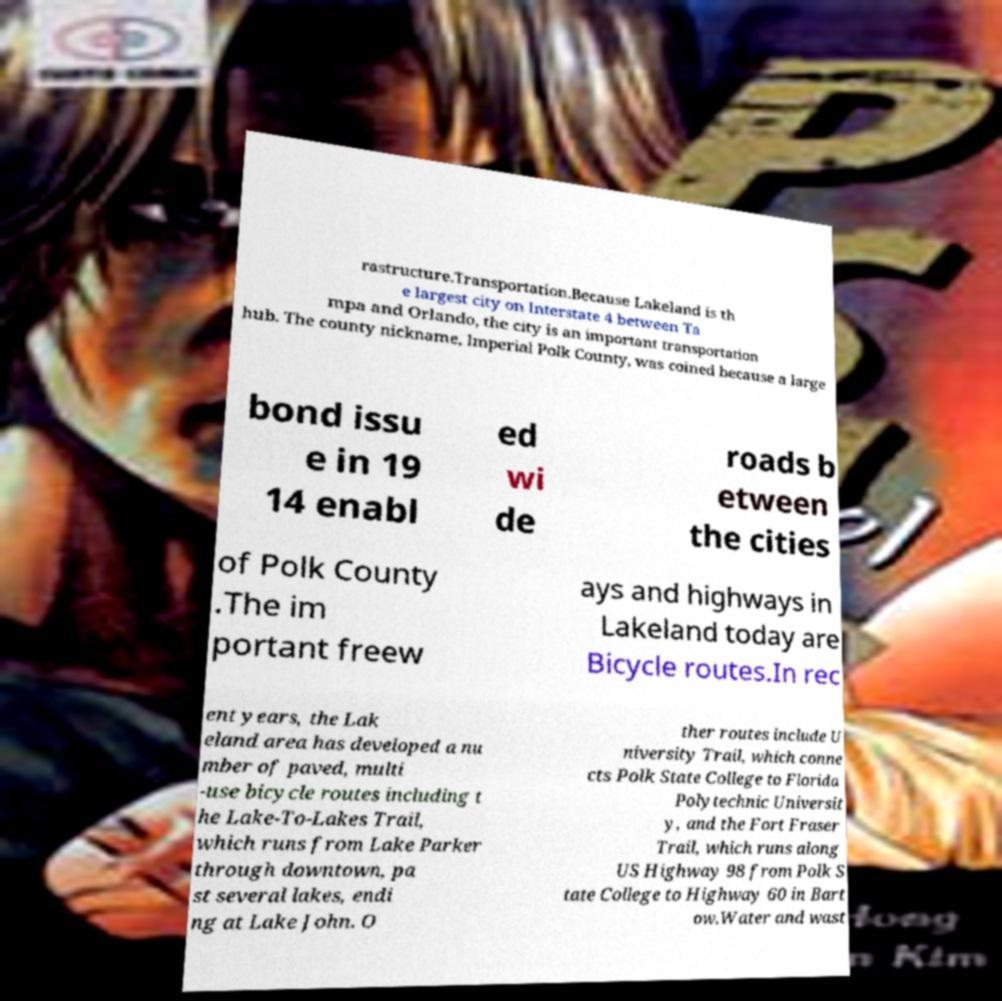I need the written content from this picture converted into text. Can you do that? rastructure.Transportation.Because Lakeland is th e largest city on Interstate 4 between Ta mpa and Orlando, the city is an important transportation hub. The county nickname, Imperial Polk County, was coined because a large bond issu e in 19 14 enabl ed wi de roads b etween the cities of Polk County .The im portant freew ays and highways in Lakeland today are Bicycle routes.In rec ent years, the Lak eland area has developed a nu mber of paved, multi -use bicycle routes including t he Lake-To-Lakes Trail, which runs from Lake Parker through downtown, pa st several lakes, endi ng at Lake John. O ther routes include U niversity Trail, which conne cts Polk State College to Florida Polytechnic Universit y, and the Fort Fraser Trail, which runs along US Highway 98 from Polk S tate College to Highway 60 in Bart ow.Water and wast 